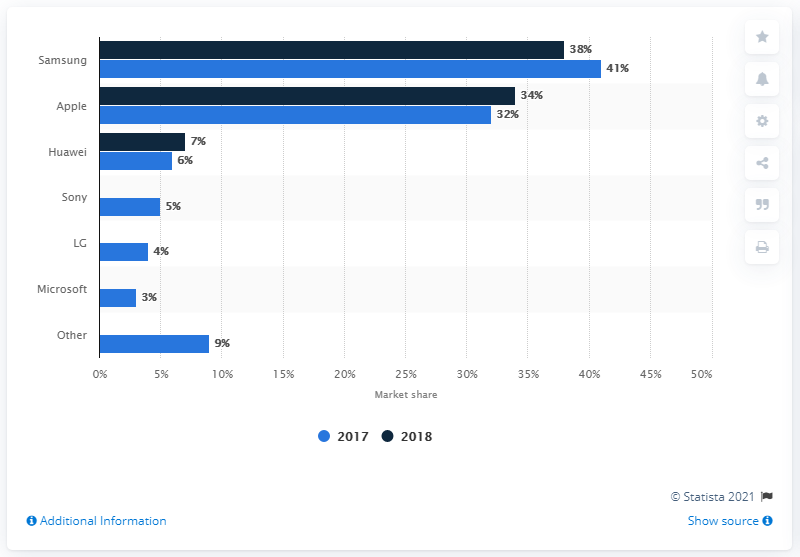Outline some significant characteristics in this image. In 2018, Apple was the second largest smartphone brand in the Netherlands in terms of market share. 